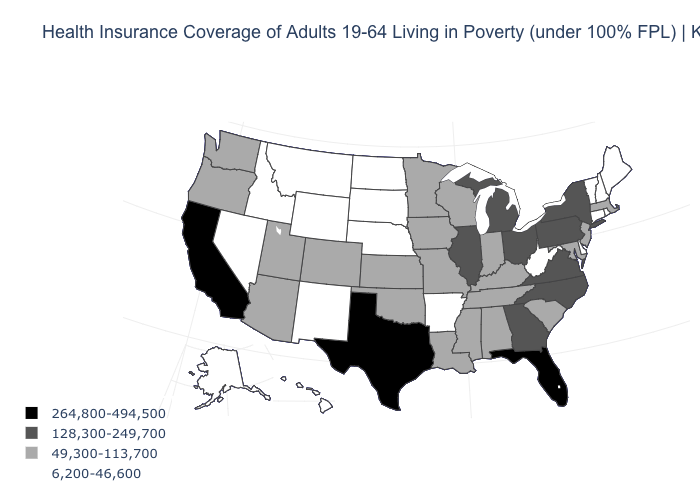Name the states that have a value in the range 6,200-46,600?
Short answer required. Alaska, Arkansas, Connecticut, Delaware, Hawaii, Idaho, Maine, Montana, Nebraska, Nevada, New Hampshire, New Mexico, North Dakota, Rhode Island, South Dakota, Vermont, West Virginia, Wyoming. Is the legend a continuous bar?
Give a very brief answer. No. Which states have the lowest value in the Northeast?
Answer briefly. Connecticut, Maine, New Hampshire, Rhode Island, Vermont. Does Nevada have the lowest value in the West?
Give a very brief answer. Yes. Name the states that have a value in the range 128,300-249,700?
Concise answer only. Georgia, Illinois, Michigan, New York, North Carolina, Ohio, Pennsylvania, Virginia. What is the value of New Hampshire?
Give a very brief answer. 6,200-46,600. Name the states that have a value in the range 6,200-46,600?
Keep it brief. Alaska, Arkansas, Connecticut, Delaware, Hawaii, Idaho, Maine, Montana, Nebraska, Nevada, New Hampshire, New Mexico, North Dakota, Rhode Island, South Dakota, Vermont, West Virginia, Wyoming. What is the value of Oregon?
Keep it brief. 49,300-113,700. Does the first symbol in the legend represent the smallest category?
Give a very brief answer. No. What is the value of South Dakota?
Quick response, please. 6,200-46,600. Is the legend a continuous bar?
Short answer required. No. Name the states that have a value in the range 49,300-113,700?
Short answer required. Alabama, Arizona, Colorado, Indiana, Iowa, Kansas, Kentucky, Louisiana, Maryland, Massachusetts, Minnesota, Mississippi, Missouri, New Jersey, Oklahoma, Oregon, South Carolina, Tennessee, Utah, Washington, Wisconsin. Among the states that border Maryland , does West Virginia have the highest value?
Write a very short answer. No. What is the highest value in states that border Arkansas?
Be succinct. 264,800-494,500. 